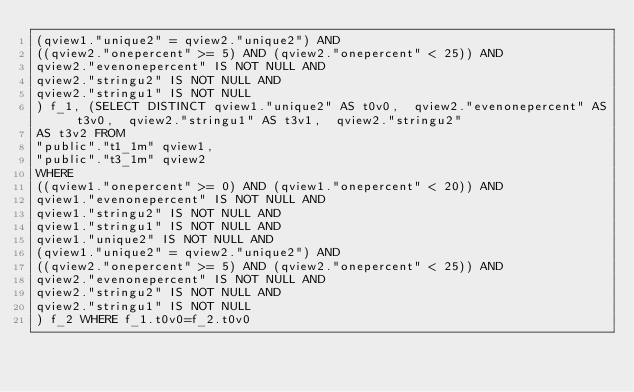<code> <loc_0><loc_0><loc_500><loc_500><_SQL_>(qview1."unique2" = qview2."unique2") AND
((qview2."onepercent" >= 5) AND (qview2."onepercent" < 25)) AND
qview2."evenonepercent" IS NOT NULL AND
qview2."stringu2" IS NOT NULL AND
qview2."stringu1" IS NOT NULL
) f_1, (SELECT DISTINCT qview1."unique2" AS t0v0,  qview2."evenonepercent" AS t3v0,  qview2."stringu1" AS t3v1,  qview2."stringu2"
AS t3v2 FROM
"public"."t1_1m" qview1,
"public"."t3_1m" qview2
WHERE
((qview1."onepercent" >= 0) AND (qview1."onepercent" < 20)) AND
qview1."evenonepercent" IS NOT NULL AND
qview1."stringu2" IS NOT NULL AND
qview1."stringu1" IS NOT NULL AND
qview1."unique2" IS NOT NULL AND
(qview1."unique2" = qview2."unique2") AND
((qview2."onepercent" >= 5) AND (qview2."onepercent" < 25)) AND
qview2."evenonepercent" IS NOT NULL AND
qview2."stringu2" IS NOT NULL AND
qview2."stringu1" IS NOT NULL
) f_2 WHERE f_1.t0v0=f_2.t0v0
</code> 